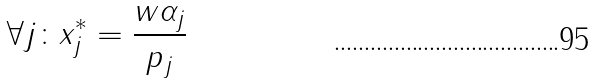<formula> <loc_0><loc_0><loc_500><loc_500>\forall j \colon x _ { j } ^ { * } = \frac { w \alpha _ { j } } { p _ { j } }</formula> 